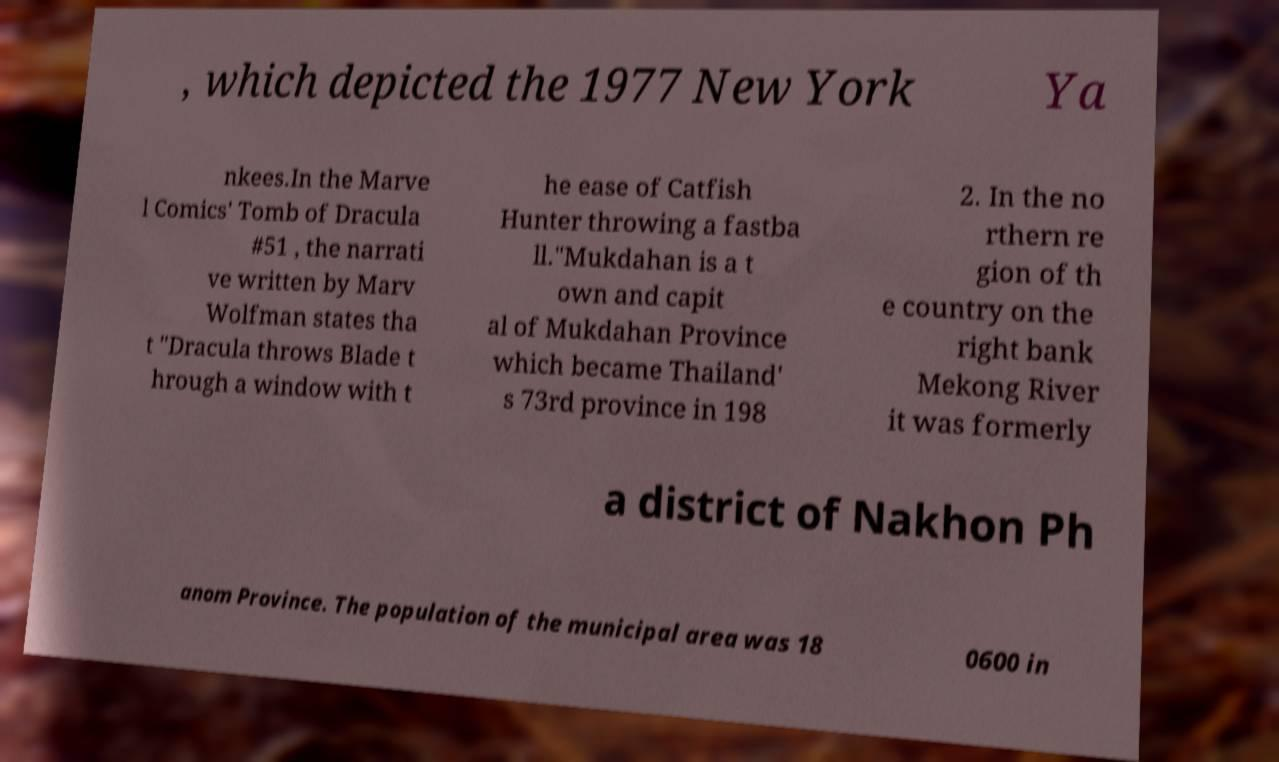Please identify and transcribe the text found in this image. , which depicted the 1977 New York Ya nkees.In the Marve l Comics' Tomb of Dracula #51 , the narrati ve written by Marv Wolfman states tha t "Dracula throws Blade t hrough a window with t he ease of Catfish Hunter throwing a fastba ll."Mukdahan is a t own and capit al of Mukdahan Province which became Thailand' s 73rd province in 198 2. In the no rthern re gion of th e country on the right bank Mekong River it was formerly a district of Nakhon Ph anom Province. The population of the municipal area was 18 0600 in 